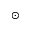Convert formula to latex. <formula><loc_0><loc_0><loc_500><loc_500>_ { \odot }</formula> 